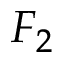<formula> <loc_0><loc_0><loc_500><loc_500>F _ { 2 }</formula> 